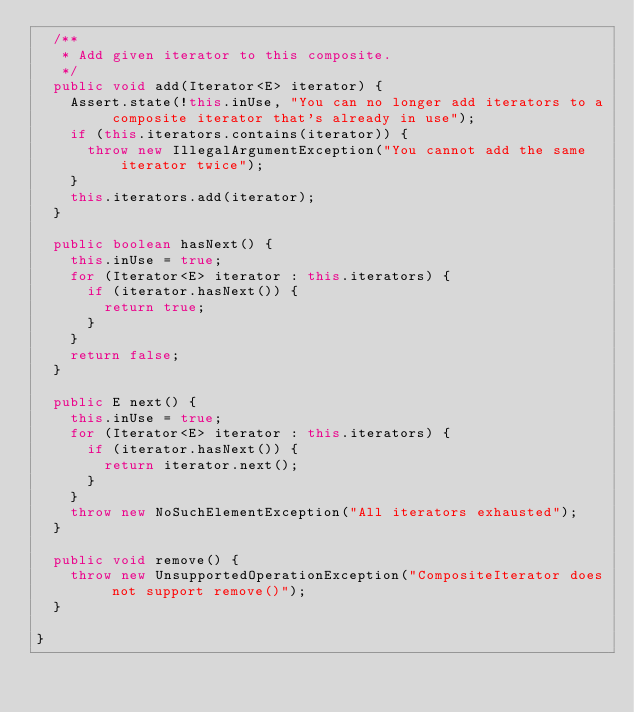<code> <loc_0><loc_0><loc_500><loc_500><_Java_>	/**
	 * Add given iterator to this composite.
	 */
	public void add(Iterator<E> iterator) {
		Assert.state(!this.inUse, "You can no longer add iterators to a composite iterator that's already in use");
		if (this.iterators.contains(iterator)) {
			throw new IllegalArgumentException("You cannot add the same iterator twice");
		}
		this.iterators.add(iterator);
	}

	public boolean hasNext() {
		this.inUse = true;
		for (Iterator<E> iterator : this.iterators) {
			if (iterator.hasNext()) {
				return true;
			}
		}
		return false;
	}

	public E next() {
		this.inUse = true;
		for (Iterator<E> iterator : this.iterators) {
			if (iterator.hasNext()) {
				return iterator.next();
			}
		}
		throw new NoSuchElementException("All iterators exhausted");
	}

	public void remove() {
		throw new UnsupportedOperationException("CompositeIterator does not support remove()");
	}

}
</code> 